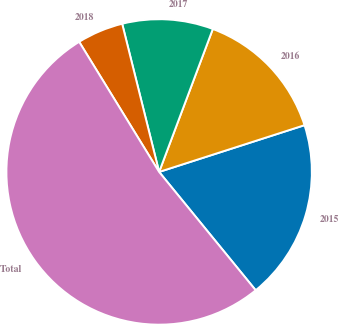Convert chart. <chart><loc_0><loc_0><loc_500><loc_500><pie_chart><fcel>2015<fcel>2016<fcel>2017<fcel>2018<fcel>Total<nl><fcel>19.06%<fcel>14.33%<fcel>9.61%<fcel>4.88%<fcel>52.13%<nl></chart> 